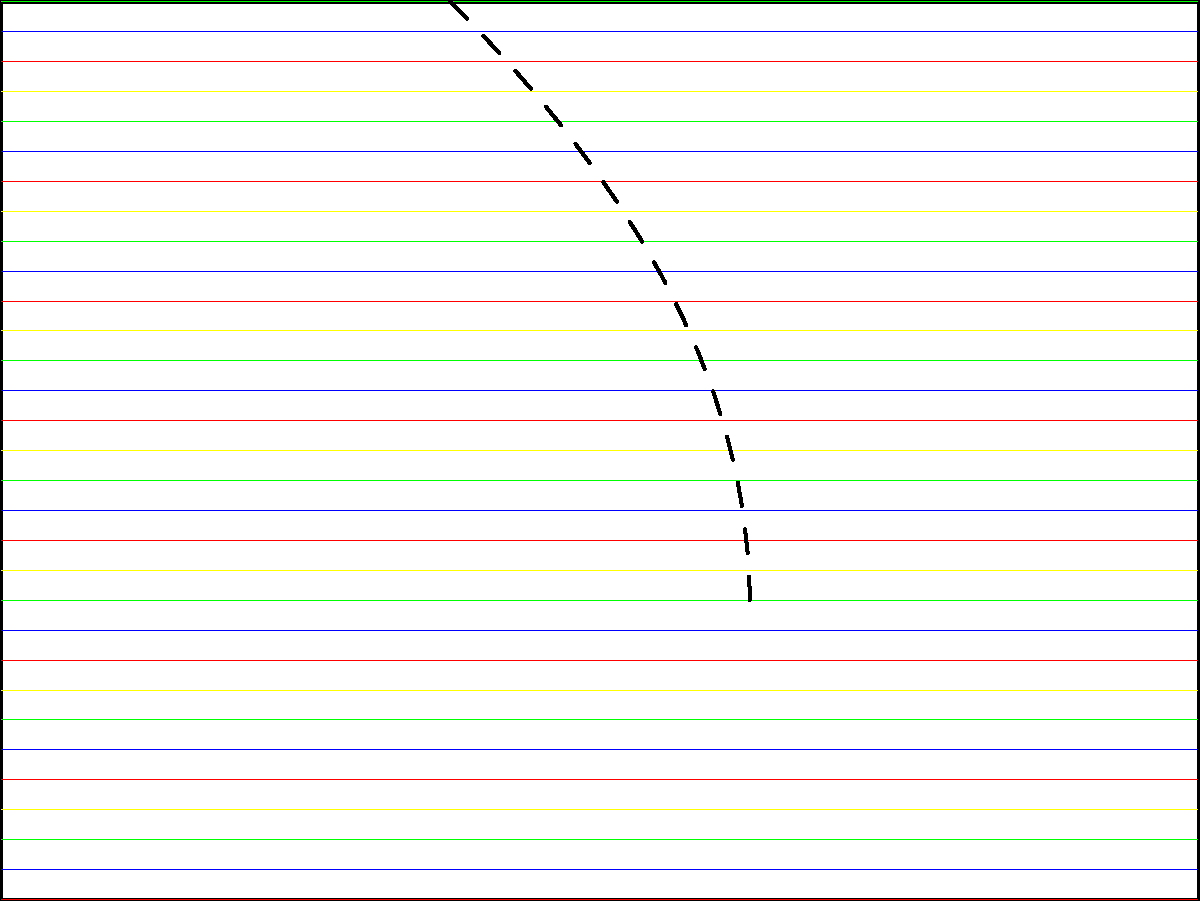As a curious kitten, you've been playing with the old woman's knitting project. The sweater has been partially unraveled, revealing a distinct yarn pattern. Based on the visible pattern, what is the correct sequence of yarn colors from top to bottom? To determine the correct sequence of yarn colors, we need to analyze the pattern visible in the intact part of the sweater:

1. Observe the top of the sweater, where the pattern is still intact.
2. Notice that the yarn colors repeat in a specific order.
3. Starting from the top, we can see the following sequence:
   - Red
   - Blue
   - Green
   - Yellow
4. This sequence repeats throughout the visible part of the sweater.
5. The unraveled section doesn't affect the original sequence, as it merely reveals the pattern underneath.
6. Therefore, the correct sequence of yarn colors from top to bottom is: Red, Blue, Green, Yellow.
Answer: Red, Blue, Green, Yellow 